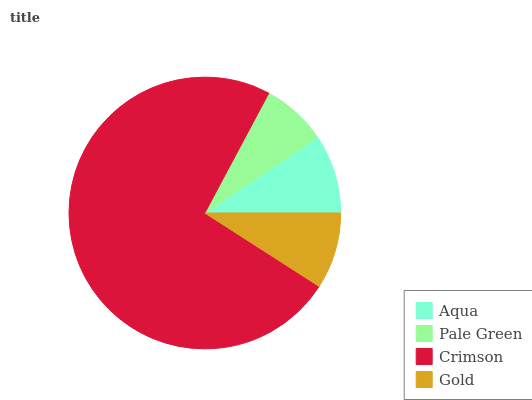Is Pale Green the minimum?
Answer yes or no. Yes. Is Crimson the maximum?
Answer yes or no. Yes. Is Crimson the minimum?
Answer yes or no. No. Is Pale Green the maximum?
Answer yes or no. No. Is Crimson greater than Pale Green?
Answer yes or no. Yes. Is Pale Green less than Crimson?
Answer yes or no. Yes. Is Pale Green greater than Crimson?
Answer yes or no. No. Is Crimson less than Pale Green?
Answer yes or no. No. Is Aqua the high median?
Answer yes or no. Yes. Is Gold the low median?
Answer yes or no. Yes. Is Pale Green the high median?
Answer yes or no. No. Is Crimson the low median?
Answer yes or no. No. 